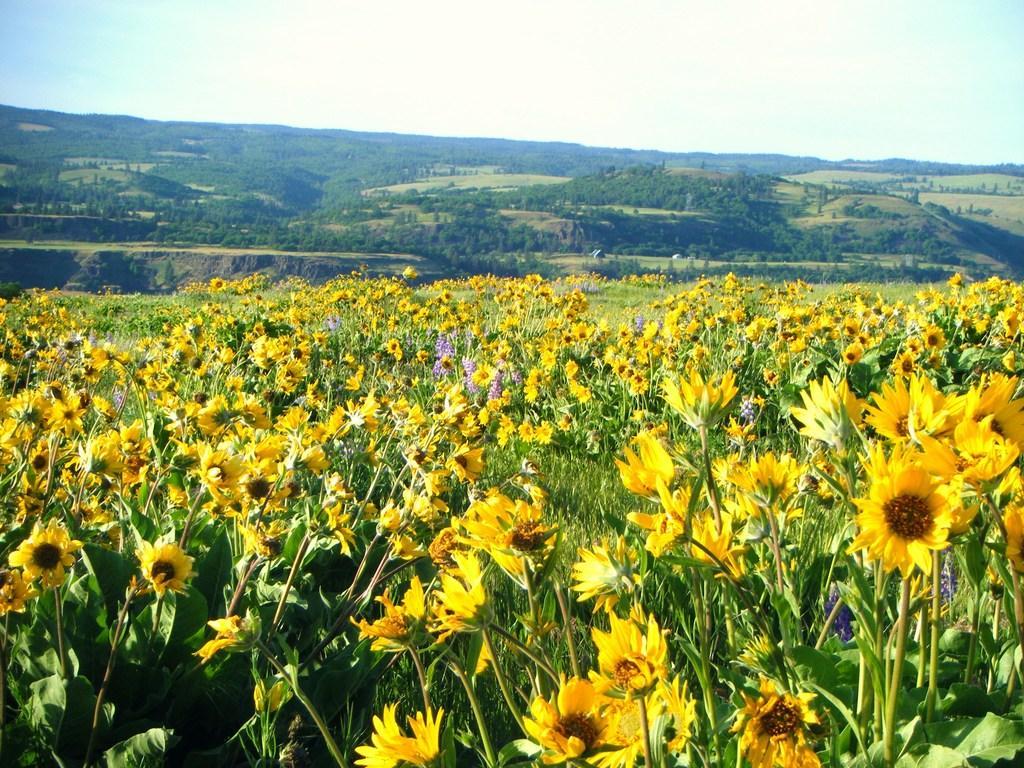How would you summarize this image in a sentence or two? In this image there are plants and we can see flowers which are in yellow color. In the background there are trees, hills and sky. 